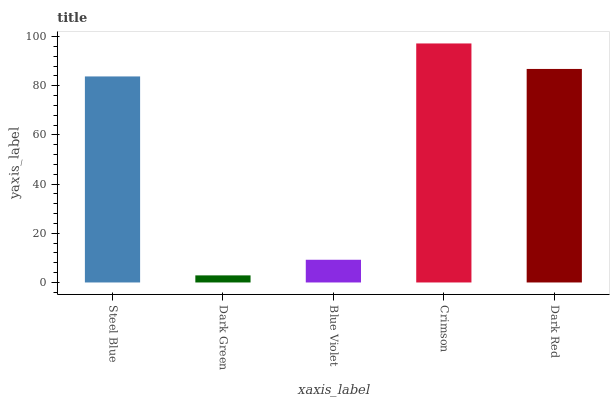Is Dark Green the minimum?
Answer yes or no. Yes. Is Crimson the maximum?
Answer yes or no. Yes. Is Blue Violet the minimum?
Answer yes or no. No. Is Blue Violet the maximum?
Answer yes or no. No. Is Blue Violet greater than Dark Green?
Answer yes or no. Yes. Is Dark Green less than Blue Violet?
Answer yes or no. Yes. Is Dark Green greater than Blue Violet?
Answer yes or no. No. Is Blue Violet less than Dark Green?
Answer yes or no. No. Is Steel Blue the high median?
Answer yes or no. Yes. Is Steel Blue the low median?
Answer yes or no. Yes. Is Dark Green the high median?
Answer yes or no. No. Is Crimson the low median?
Answer yes or no. No. 